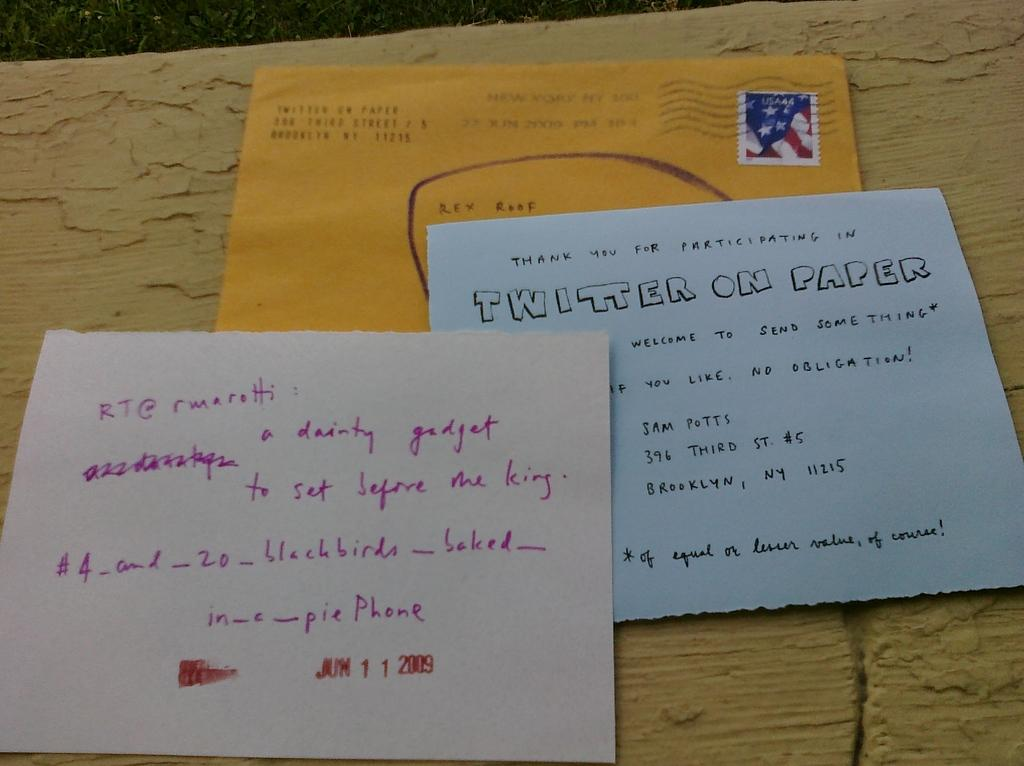<image>
Summarize the visual content of the image. An envelope and two pieces of paper one that says Twitter On Paper. 